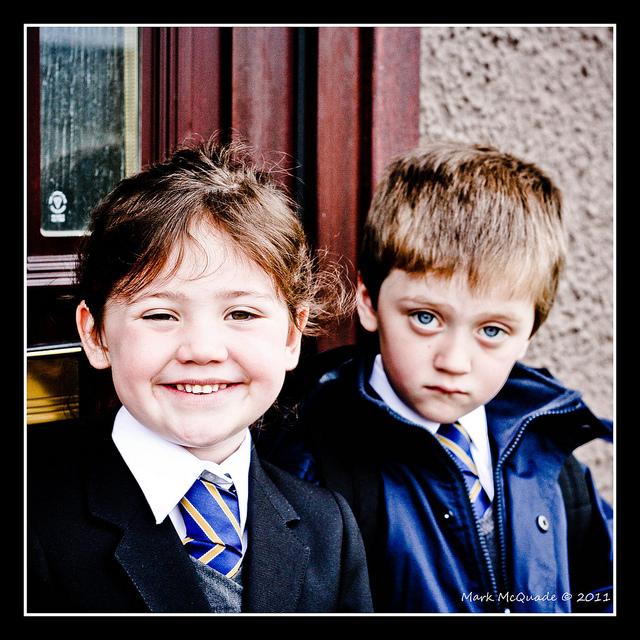Do the people in this scene look like they work in an office?
Concise answer only. No. What kind of knot is tied in this tie?
Be succinct. Windsor. Are they happy?
Concise answer only. Yes. Are these young people?
Write a very short answer. Yes. Are both children smiling?
Give a very brief answer. No. Does this boy look happy?
Give a very brief answer. Yes. How many children are there?
Keep it brief. 2. Are both children wearing the same color tie?
Quick response, please. Yes. Is the boy dressed for an official occasion?
Quick response, please. Yes. 